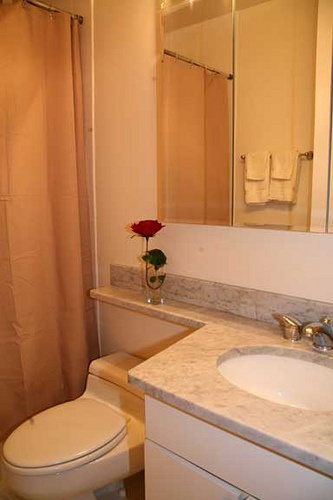Describe the objects in this image and their specific colors. I can see toilet in maroon, tan, gray, and brown tones, sink in maroon and tan tones, vase in maroon, brown, and gray tones, and cup in maroon, brown, and gray tones in this image. 